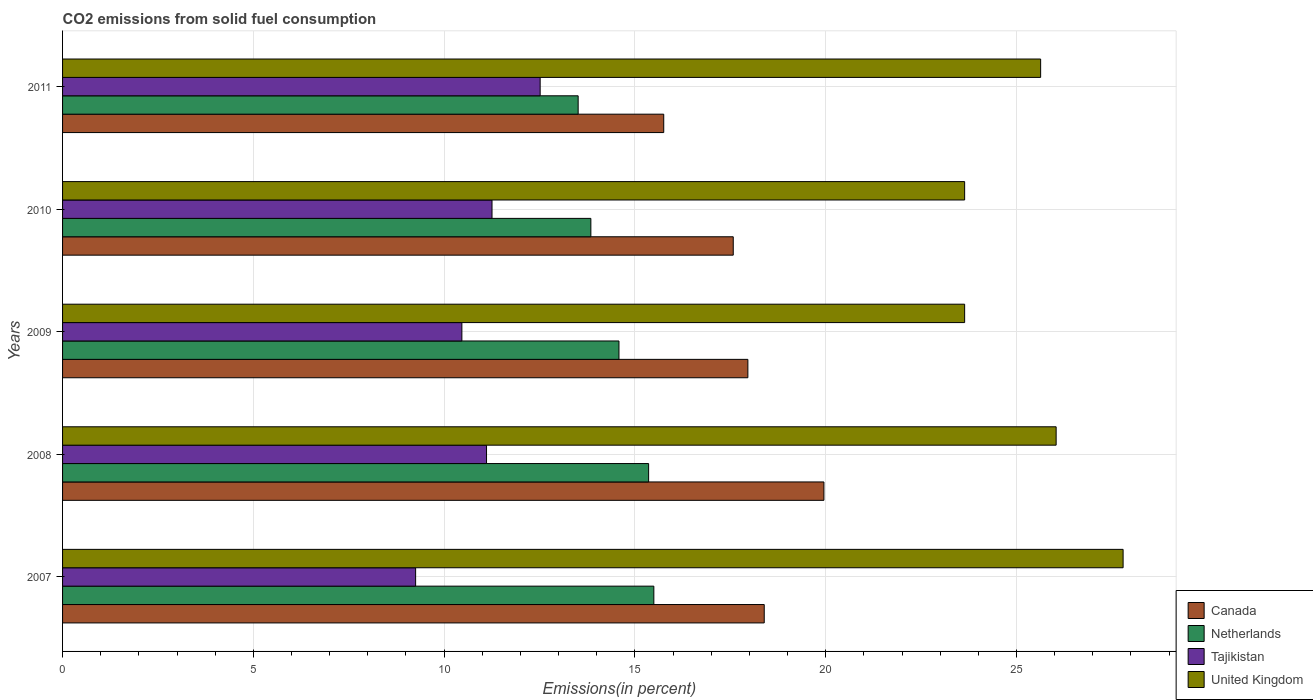Are the number of bars per tick equal to the number of legend labels?
Your answer should be very brief. Yes. Are the number of bars on each tick of the Y-axis equal?
Make the answer very short. Yes. How many bars are there on the 5th tick from the top?
Offer a very short reply. 4. What is the label of the 5th group of bars from the top?
Your answer should be compact. 2007. In how many cases, is the number of bars for a given year not equal to the number of legend labels?
Your response must be concise. 0. What is the total CO2 emitted in Netherlands in 2007?
Offer a very short reply. 15.5. Across all years, what is the maximum total CO2 emitted in Netherlands?
Your response must be concise. 15.5. Across all years, what is the minimum total CO2 emitted in Tajikistan?
Give a very brief answer. 9.25. In which year was the total CO2 emitted in Canada maximum?
Offer a very short reply. 2008. What is the total total CO2 emitted in United Kingdom in the graph?
Offer a terse response. 126.75. What is the difference between the total CO2 emitted in Netherlands in 2009 and that in 2010?
Provide a short and direct response. 0.74. What is the difference between the total CO2 emitted in Netherlands in 2009 and the total CO2 emitted in United Kingdom in 2007?
Offer a terse response. -13.21. What is the average total CO2 emitted in Tajikistan per year?
Provide a succinct answer. 10.92. In the year 2011, what is the difference between the total CO2 emitted in Netherlands and total CO2 emitted in United Kingdom?
Your response must be concise. -12.12. In how many years, is the total CO2 emitted in Tajikistan greater than 28 %?
Provide a short and direct response. 0. What is the ratio of the total CO2 emitted in Tajikistan in 2009 to that in 2011?
Make the answer very short. 0.84. What is the difference between the highest and the second highest total CO2 emitted in Tajikistan?
Keep it short and to the point. 1.26. What is the difference between the highest and the lowest total CO2 emitted in Tajikistan?
Ensure brevity in your answer.  3.26. In how many years, is the total CO2 emitted in Canada greater than the average total CO2 emitted in Canada taken over all years?
Offer a terse response. 3. Is the sum of the total CO2 emitted in Netherlands in 2009 and 2010 greater than the maximum total CO2 emitted in United Kingdom across all years?
Ensure brevity in your answer.  Yes. Is it the case that in every year, the sum of the total CO2 emitted in Tajikistan and total CO2 emitted in Netherlands is greater than the sum of total CO2 emitted in Canada and total CO2 emitted in United Kingdom?
Offer a very short reply. No. What does the 3rd bar from the top in 2008 represents?
Make the answer very short. Netherlands. How many legend labels are there?
Provide a succinct answer. 4. What is the title of the graph?
Your answer should be very brief. CO2 emissions from solid fuel consumption. What is the label or title of the X-axis?
Make the answer very short. Emissions(in percent). What is the label or title of the Y-axis?
Ensure brevity in your answer.  Years. What is the Emissions(in percent) of Canada in 2007?
Keep it short and to the point. 18.39. What is the Emissions(in percent) in Netherlands in 2007?
Keep it short and to the point. 15.5. What is the Emissions(in percent) in Tajikistan in 2007?
Your response must be concise. 9.25. What is the Emissions(in percent) in United Kingdom in 2007?
Give a very brief answer. 27.79. What is the Emissions(in percent) in Canada in 2008?
Keep it short and to the point. 19.95. What is the Emissions(in percent) of Netherlands in 2008?
Offer a terse response. 15.36. What is the Emissions(in percent) in Tajikistan in 2008?
Your answer should be compact. 11.11. What is the Emissions(in percent) of United Kingdom in 2008?
Your response must be concise. 26.04. What is the Emissions(in percent) of Canada in 2009?
Provide a short and direct response. 17.96. What is the Emissions(in percent) of Netherlands in 2009?
Offer a very short reply. 14.58. What is the Emissions(in percent) of Tajikistan in 2009?
Your answer should be compact. 10.47. What is the Emissions(in percent) in United Kingdom in 2009?
Offer a very short reply. 23.64. What is the Emissions(in percent) of Canada in 2010?
Keep it short and to the point. 17.58. What is the Emissions(in percent) of Netherlands in 2010?
Ensure brevity in your answer.  13.85. What is the Emissions(in percent) of Tajikistan in 2010?
Your answer should be compact. 11.25. What is the Emissions(in percent) in United Kingdom in 2010?
Offer a terse response. 23.64. What is the Emissions(in percent) of Canada in 2011?
Offer a terse response. 15.76. What is the Emissions(in percent) of Netherlands in 2011?
Your answer should be very brief. 13.51. What is the Emissions(in percent) of Tajikistan in 2011?
Your answer should be very brief. 12.52. What is the Emissions(in percent) of United Kingdom in 2011?
Provide a short and direct response. 25.63. Across all years, what is the maximum Emissions(in percent) in Canada?
Your answer should be very brief. 19.95. Across all years, what is the maximum Emissions(in percent) in Netherlands?
Give a very brief answer. 15.5. Across all years, what is the maximum Emissions(in percent) in Tajikistan?
Ensure brevity in your answer.  12.52. Across all years, what is the maximum Emissions(in percent) of United Kingdom?
Your answer should be compact. 27.79. Across all years, what is the minimum Emissions(in percent) in Canada?
Ensure brevity in your answer.  15.76. Across all years, what is the minimum Emissions(in percent) of Netherlands?
Your response must be concise. 13.51. Across all years, what is the minimum Emissions(in percent) in Tajikistan?
Your answer should be very brief. 9.25. Across all years, what is the minimum Emissions(in percent) of United Kingdom?
Offer a very short reply. 23.64. What is the total Emissions(in percent) of Canada in the graph?
Make the answer very short. 89.64. What is the total Emissions(in percent) of Netherlands in the graph?
Provide a short and direct response. 72.8. What is the total Emissions(in percent) of Tajikistan in the graph?
Offer a very short reply. 54.6. What is the total Emissions(in percent) of United Kingdom in the graph?
Your answer should be very brief. 126.75. What is the difference between the Emissions(in percent) of Canada in 2007 and that in 2008?
Make the answer very short. -1.56. What is the difference between the Emissions(in percent) in Netherlands in 2007 and that in 2008?
Keep it short and to the point. 0.14. What is the difference between the Emissions(in percent) in Tajikistan in 2007 and that in 2008?
Provide a short and direct response. -1.86. What is the difference between the Emissions(in percent) in United Kingdom in 2007 and that in 2008?
Your answer should be compact. 1.75. What is the difference between the Emissions(in percent) of Canada in 2007 and that in 2009?
Ensure brevity in your answer.  0.43. What is the difference between the Emissions(in percent) of Netherlands in 2007 and that in 2009?
Give a very brief answer. 0.91. What is the difference between the Emissions(in percent) in Tajikistan in 2007 and that in 2009?
Offer a terse response. -1.21. What is the difference between the Emissions(in percent) in United Kingdom in 2007 and that in 2009?
Offer a terse response. 4.15. What is the difference between the Emissions(in percent) in Canada in 2007 and that in 2010?
Provide a short and direct response. 0.81. What is the difference between the Emissions(in percent) of Netherlands in 2007 and that in 2010?
Ensure brevity in your answer.  1.65. What is the difference between the Emissions(in percent) in Tajikistan in 2007 and that in 2010?
Ensure brevity in your answer.  -2. What is the difference between the Emissions(in percent) in United Kingdom in 2007 and that in 2010?
Keep it short and to the point. 4.15. What is the difference between the Emissions(in percent) of Canada in 2007 and that in 2011?
Offer a very short reply. 2.63. What is the difference between the Emissions(in percent) in Netherlands in 2007 and that in 2011?
Offer a terse response. 1.98. What is the difference between the Emissions(in percent) in Tajikistan in 2007 and that in 2011?
Give a very brief answer. -3.26. What is the difference between the Emissions(in percent) of United Kingdom in 2007 and that in 2011?
Your answer should be very brief. 2.16. What is the difference between the Emissions(in percent) of Canada in 2008 and that in 2009?
Ensure brevity in your answer.  1.99. What is the difference between the Emissions(in percent) in Netherlands in 2008 and that in 2009?
Your response must be concise. 0.78. What is the difference between the Emissions(in percent) of Tajikistan in 2008 and that in 2009?
Provide a succinct answer. 0.65. What is the difference between the Emissions(in percent) in United Kingdom in 2008 and that in 2009?
Your answer should be compact. 2.4. What is the difference between the Emissions(in percent) in Canada in 2008 and that in 2010?
Your answer should be compact. 2.38. What is the difference between the Emissions(in percent) in Netherlands in 2008 and that in 2010?
Ensure brevity in your answer.  1.51. What is the difference between the Emissions(in percent) in Tajikistan in 2008 and that in 2010?
Keep it short and to the point. -0.14. What is the difference between the Emissions(in percent) in United Kingdom in 2008 and that in 2010?
Provide a short and direct response. 2.4. What is the difference between the Emissions(in percent) in Canada in 2008 and that in 2011?
Provide a short and direct response. 4.2. What is the difference between the Emissions(in percent) in Netherlands in 2008 and that in 2011?
Offer a terse response. 1.85. What is the difference between the Emissions(in percent) in Tajikistan in 2008 and that in 2011?
Make the answer very short. -1.41. What is the difference between the Emissions(in percent) of United Kingdom in 2008 and that in 2011?
Your answer should be compact. 0.41. What is the difference between the Emissions(in percent) in Canada in 2009 and that in 2010?
Provide a short and direct response. 0.38. What is the difference between the Emissions(in percent) of Netherlands in 2009 and that in 2010?
Make the answer very short. 0.74. What is the difference between the Emissions(in percent) in Tajikistan in 2009 and that in 2010?
Make the answer very short. -0.79. What is the difference between the Emissions(in percent) in Canada in 2009 and that in 2011?
Give a very brief answer. 2.21. What is the difference between the Emissions(in percent) of Netherlands in 2009 and that in 2011?
Your answer should be very brief. 1.07. What is the difference between the Emissions(in percent) in Tajikistan in 2009 and that in 2011?
Give a very brief answer. -2.05. What is the difference between the Emissions(in percent) in United Kingdom in 2009 and that in 2011?
Your answer should be compact. -1.99. What is the difference between the Emissions(in percent) in Canada in 2010 and that in 2011?
Make the answer very short. 1.82. What is the difference between the Emissions(in percent) in Netherlands in 2010 and that in 2011?
Provide a succinct answer. 0.33. What is the difference between the Emissions(in percent) in Tajikistan in 2010 and that in 2011?
Provide a succinct answer. -1.26. What is the difference between the Emissions(in percent) in United Kingdom in 2010 and that in 2011?
Provide a short and direct response. -1.99. What is the difference between the Emissions(in percent) of Canada in 2007 and the Emissions(in percent) of Netherlands in 2008?
Offer a terse response. 3.03. What is the difference between the Emissions(in percent) of Canada in 2007 and the Emissions(in percent) of Tajikistan in 2008?
Make the answer very short. 7.28. What is the difference between the Emissions(in percent) in Canada in 2007 and the Emissions(in percent) in United Kingdom in 2008?
Make the answer very short. -7.65. What is the difference between the Emissions(in percent) in Netherlands in 2007 and the Emissions(in percent) in Tajikistan in 2008?
Your answer should be very brief. 4.39. What is the difference between the Emissions(in percent) of Netherlands in 2007 and the Emissions(in percent) of United Kingdom in 2008?
Keep it short and to the point. -10.54. What is the difference between the Emissions(in percent) in Tajikistan in 2007 and the Emissions(in percent) in United Kingdom in 2008?
Your response must be concise. -16.79. What is the difference between the Emissions(in percent) in Canada in 2007 and the Emissions(in percent) in Netherlands in 2009?
Offer a very short reply. 3.81. What is the difference between the Emissions(in percent) in Canada in 2007 and the Emissions(in percent) in Tajikistan in 2009?
Offer a terse response. 7.92. What is the difference between the Emissions(in percent) in Canada in 2007 and the Emissions(in percent) in United Kingdom in 2009?
Provide a short and direct response. -5.25. What is the difference between the Emissions(in percent) of Netherlands in 2007 and the Emissions(in percent) of Tajikistan in 2009?
Ensure brevity in your answer.  5.03. What is the difference between the Emissions(in percent) of Netherlands in 2007 and the Emissions(in percent) of United Kingdom in 2009?
Make the answer very short. -8.15. What is the difference between the Emissions(in percent) in Tajikistan in 2007 and the Emissions(in percent) in United Kingdom in 2009?
Offer a terse response. -14.39. What is the difference between the Emissions(in percent) in Canada in 2007 and the Emissions(in percent) in Netherlands in 2010?
Keep it short and to the point. 4.54. What is the difference between the Emissions(in percent) in Canada in 2007 and the Emissions(in percent) in Tajikistan in 2010?
Your response must be concise. 7.13. What is the difference between the Emissions(in percent) of Canada in 2007 and the Emissions(in percent) of United Kingdom in 2010?
Make the answer very short. -5.25. What is the difference between the Emissions(in percent) in Netherlands in 2007 and the Emissions(in percent) in Tajikistan in 2010?
Ensure brevity in your answer.  4.24. What is the difference between the Emissions(in percent) of Netherlands in 2007 and the Emissions(in percent) of United Kingdom in 2010?
Your answer should be very brief. -8.15. What is the difference between the Emissions(in percent) in Tajikistan in 2007 and the Emissions(in percent) in United Kingdom in 2010?
Your answer should be compact. -14.39. What is the difference between the Emissions(in percent) of Canada in 2007 and the Emissions(in percent) of Netherlands in 2011?
Make the answer very short. 4.88. What is the difference between the Emissions(in percent) of Canada in 2007 and the Emissions(in percent) of Tajikistan in 2011?
Ensure brevity in your answer.  5.87. What is the difference between the Emissions(in percent) in Canada in 2007 and the Emissions(in percent) in United Kingdom in 2011?
Ensure brevity in your answer.  -7.24. What is the difference between the Emissions(in percent) of Netherlands in 2007 and the Emissions(in percent) of Tajikistan in 2011?
Offer a very short reply. 2.98. What is the difference between the Emissions(in percent) of Netherlands in 2007 and the Emissions(in percent) of United Kingdom in 2011?
Your answer should be compact. -10.14. What is the difference between the Emissions(in percent) of Tajikistan in 2007 and the Emissions(in percent) of United Kingdom in 2011?
Your answer should be compact. -16.38. What is the difference between the Emissions(in percent) in Canada in 2008 and the Emissions(in percent) in Netherlands in 2009?
Make the answer very short. 5.37. What is the difference between the Emissions(in percent) in Canada in 2008 and the Emissions(in percent) in Tajikistan in 2009?
Your answer should be very brief. 9.49. What is the difference between the Emissions(in percent) of Canada in 2008 and the Emissions(in percent) of United Kingdom in 2009?
Your answer should be compact. -3.69. What is the difference between the Emissions(in percent) in Netherlands in 2008 and the Emissions(in percent) in Tajikistan in 2009?
Give a very brief answer. 4.89. What is the difference between the Emissions(in percent) of Netherlands in 2008 and the Emissions(in percent) of United Kingdom in 2009?
Give a very brief answer. -8.28. What is the difference between the Emissions(in percent) in Tajikistan in 2008 and the Emissions(in percent) in United Kingdom in 2009?
Make the answer very short. -12.53. What is the difference between the Emissions(in percent) in Canada in 2008 and the Emissions(in percent) in Netherlands in 2010?
Make the answer very short. 6.11. What is the difference between the Emissions(in percent) of Canada in 2008 and the Emissions(in percent) of Tajikistan in 2010?
Offer a very short reply. 8.7. What is the difference between the Emissions(in percent) in Canada in 2008 and the Emissions(in percent) in United Kingdom in 2010?
Provide a short and direct response. -3.69. What is the difference between the Emissions(in percent) of Netherlands in 2008 and the Emissions(in percent) of Tajikistan in 2010?
Your response must be concise. 4.1. What is the difference between the Emissions(in percent) of Netherlands in 2008 and the Emissions(in percent) of United Kingdom in 2010?
Give a very brief answer. -8.28. What is the difference between the Emissions(in percent) of Tajikistan in 2008 and the Emissions(in percent) of United Kingdom in 2010?
Give a very brief answer. -12.53. What is the difference between the Emissions(in percent) of Canada in 2008 and the Emissions(in percent) of Netherlands in 2011?
Your response must be concise. 6.44. What is the difference between the Emissions(in percent) in Canada in 2008 and the Emissions(in percent) in Tajikistan in 2011?
Give a very brief answer. 7.44. What is the difference between the Emissions(in percent) of Canada in 2008 and the Emissions(in percent) of United Kingdom in 2011?
Offer a terse response. -5.68. What is the difference between the Emissions(in percent) of Netherlands in 2008 and the Emissions(in percent) of Tajikistan in 2011?
Offer a terse response. 2.84. What is the difference between the Emissions(in percent) of Netherlands in 2008 and the Emissions(in percent) of United Kingdom in 2011?
Provide a short and direct response. -10.27. What is the difference between the Emissions(in percent) in Tajikistan in 2008 and the Emissions(in percent) in United Kingdom in 2011?
Ensure brevity in your answer.  -14.52. What is the difference between the Emissions(in percent) in Canada in 2009 and the Emissions(in percent) in Netherlands in 2010?
Keep it short and to the point. 4.12. What is the difference between the Emissions(in percent) of Canada in 2009 and the Emissions(in percent) of Tajikistan in 2010?
Give a very brief answer. 6.71. What is the difference between the Emissions(in percent) in Canada in 2009 and the Emissions(in percent) in United Kingdom in 2010?
Make the answer very short. -5.68. What is the difference between the Emissions(in percent) of Netherlands in 2009 and the Emissions(in percent) of Tajikistan in 2010?
Offer a very short reply. 3.33. What is the difference between the Emissions(in percent) of Netherlands in 2009 and the Emissions(in percent) of United Kingdom in 2010?
Your answer should be very brief. -9.06. What is the difference between the Emissions(in percent) in Tajikistan in 2009 and the Emissions(in percent) in United Kingdom in 2010?
Ensure brevity in your answer.  -13.18. What is the difference between the Emissions(in percent) of Canada in 2009 and the Emissions(in percent) of Netherlands in 2011?
Provide a succinct answer. 4.45. What is the difference between the Emissions(in percent) of Canada in 2009 and the Emissions(in percent) of Tajikistan in 2011?
Provide a short and direct response. 5.44. What is the difference between the Emissions(in percent) of Canada in 2009 and the Emissions(in percent) of United Kingdom in 2011?
Your response must be concise. -7.67. What is the difference between the Emissions(in percent) of Netherlands in 2009 and the Emissions(in percent) of Tajikistan in 2011?
Make the answer very short. 2.07. What is the difference between the Emissions(in percent) in Netherlands in 2009 and the Emissions(in percent) in United Kingdom in 2011?
Your answer should be compact. -11.05. What is the difference between the Emissions(in percent) of Tajikistan in 2009 and the Emissions(in percent) of United Kingdom in 2011?
Keep it short and to the point. -15.17. What is the difference between the Emissions(in percent) in Canada in 2010 and the Emissions(in percent) in Netherlands in 2011?
Provide a succinct answer. 4.06. What is the difference between the Emissions(in percent) of Canada in 2010 and the Emissions(in percent) of Tajikistan in 2011?
Ensure brevity in your answer.  5.06. What is the difference between the Emissions(in percent) of Canada in 2010 and the Emissions(in percent) of United Kingdom in 2011?
Keep it short and to the point. -8.06. What is the difference between the Emissions(in percent) in Netherlands in 2010 and the Emissions(in percent) in Tajikistan in 2011?
Your response must be concise. 1.33. What is the difference between the Emissions(in percent) of Netherlands in 2010 and the Emissions(in percent) of United Kingdom in 2011?
Give a very brief answer. -11.79. What is the difference between the Emissions(in percent) of Tajikistan in 2010 and the Emissions(in percent) of United Kingdom in 2011?
Ensure brevity in your answer.  -14.38. What is the average Emissions(in percent) of Canada per year?
Give a very brief answer. 17.93. What is the average Emissions(in percent) of Netherlands per year?
Give a very brief answer. 14.56. What is the average Emissions(in percent) in Tajikistan per year?
Offer a terse response. 10.92. What is the average Emissions(in percent) of United Kingdom per year?
Make the answer very short. 25.35. In the year 2007, what is the difference between the Emissions(in percent) in Canada and Emissions(in percent) in Netherlands?
Make the answer very short. 2.89. In the year 2007, what is the difference between the Emissions(in percent) in Canada and Emissions(in percent) in Tajikistan?
Make the answer very short. 9.14. In the year 2007, what is the difference between the Emissions(in percent) of Canada and Emissions(in percent) of United Kingdom?
Keep it short and to the point. -9.41. In the year 2007, what is the difference between the Emissions(in percent) of Netherlands and Emissions(in percent) of Tajikistan?
Keep it short and to the point. 6.24. In the year 2007, what is the difference between the Emissions(in percent) in Netherlands and Emissions(in percent) in United Kingdom?
Keep it short and to the point. -12.3. In the year 2007, what is the difference between the Emissions(in percent) of Tajikistan and Emissions(in percent) of United Kingdom?
Offer a very short reply. -18.54. In the year 2008, what is the difference between the Emissions(in percent) of Canada and Emissions(in percent) of Netherlands?
Provide a short and direct response. 4.59. In the year 2008, what is the difference between the Emissions(in percent) of Canada and Emissions(in percent) of Tajikistan?
Provide a short and direct response. 8.84. In the year 2008, what is the difference between the Emissions(in percent) of Canada and Emissions(in percent) of United Kingdom?
Give a very brief answer. -6.09. In the year 2008, what is the difference between the Emissions(in percent) in Netherlands and Emissions(in percent) in Tajikistan?
Ensure brevity in your answer.  4.25. In the year 2008, what is the difference between the Emissions(in percent) in Netherlands and Emissions(in percent) in United Kingdom?
Offer a terse response. -10.68. In the year 2008, what is the difference between the Emissions(in percent) of Tajikistan and Emissions(in percent) of United Kingdom?
Your response must be concise. -14.93. In the year 2009, what is the difference between the Emissions(in percent) in Canada and Emissions(in percent) in Netherlands?
Your answer should be compact. 3.38. In the year 2009, what is the difference between the Emissions(in percent) in Canada and Emissions(in percent) in Tajikistan?
Offer a very short reply. 7.5. In the year 2009, what is the difference between the Emissions(in percent) of Canada and Emissions(in percent) of United Kingdom?
Keep it short and to the point. -5.68. In the year 2009, what is the difference between the Emissions(in percent) in Netherlands and Emissions(in percent) in Tajikistan?
Offer a terse response. 4.12. In the year 2009, what is the difference between the Emissions(in percent) of Netherlands and Emissions(in percent) of United Kingdom?
Make the answer very short. -9.06. In the year 2009, what is the difference between the Emissions(in percent) of Tajikistan and Emissions(in percent) of United Kingdom?
Ensure brevity in your answer.  -13.18. In the year 2010, what is the difference between the Emissions(in percent) of Canada and Emissions(in percent) of Netherlands?
Provide a succinct answer. 3.73. In the year 2010, what is the difference between the Emissions(in percent) of Canada and Emissions(in percent) of Tajikistan?
Ensure brevity in your answer.  6.32. In the year 2010, what is the difference between the Emissions(in percent) of Canada and Emissions(in percent) of United Kingdom?
Give a very brief answer. -6.06. In the year 2010, what is the difference between the Emissions(in percent) in Netherlands and Emissions(in percent) in Tajikistan?
Your response must be concise. 2.59. In the year 2010, what is the difference between the Emissions(in percent) in Netherlands and Emissions(in percent) in United Kingdom?
Keep it short and to the point. -9.8. In the year 2010, what is the difference between the Emissions(in percent) of Tajikistan and Emissions(in percent) of United Kingdom?
Your answer should be very brief. -12.39. In the year 2011, what is the difference between the Emissions(in percent) in Canada and Emissions(in percent) in Netherlands?
Give a very brief answer. 2.24. In the year 2011, what is the difference between the Emissions(in percent) in Canada and Emissions(in percent) in Tajikistan?
Ensure brevity in your answer.  3.24. In the year 2011, what is the difference between the Emissions(in percent) of Canada and Emissions(in percent) of United Kingdom?
Your answer should be very brief. -9.88. In the year 2011, what is the difference between the Emissions(in percent) of Netherlands and Emissions(in percent) of Tajikistan?
Provide a short and direct response. 1. In the year 2011, what is the difference between the Emissions(in percent) of Netherlands and Emissions(in percent) of United Kingdom?
Ensure brevity in your answer.  -12.12. In the year 2011, what is the difference between the Emissions(in percent) in Tajikistan and Emissions(in percent) in United Kingdom?
Provide a succinct answer. -13.12. What is the ratio of the Emissions(in percent) of Canada in 2007 to that in 2008?
Ensure brevity in your answer.  0.92. What is the ratio of the Emissions(in percent) in Netherlands in 2007 to that in 2008?
Ensure brevity in your answer.  1.01. What is the ratio of the Emissions(in percent) in Tajikistan in 2007 to that in 2008?
Offer a terse response. 0.83. What is the ratio of the Emissions(in percent) in United Kingdom in 2007 to that in 2008?
Provide a short and direct response. 1.07. What is the ratio of the Emissions(in percent) of Canada in 2007 to that in 2009?
Provide a succinct answer. 1.02. What is the ratio of the Emissions(in percent) in Netherlands in 2007 to that in 2009?
Ensure brevity in your answer.  1.06. What is the ratio of the Emissions(in percent) in Tajikistan in 2007 to that in 2009?
Provide a short and direct response. 0.88. What is the ratio of the Emissions(in percent) of United Kingdom in 2007 to that in 2009?
Make the answer very short. 1.18. What is the ratio of the Emissions(in percent) in Canada in 2007 to that in 2010?
Give a very brief answer. 1.05. What is the ratio of the Emissions(in percent) in Netherlands in 2007 to that in 2010?
Give a very brief answer. 1.12. What is the ratio of the Emissions(in percent) in Tajikistan in 2007 to that in 2010?
Ensure brevity in your answer.  0.82. What is the ratio of the Emissions(in percent) in United Kingdom in 2007 to that in 2010?
Offer a very short reply. 1.18. What is the ratio of the Emissions(in percent) in Canada in 2007 to that in 2011?
Make the answer very short. 1.17. What is the ratio of the Emissions(in percent) of Netherlands in 2007 to that in 2011?
Give a very brief answer. 1.15. What is the ratio of the Emissions(in percent) of Tajikistan in 2007 to that in 2011?
Your response must be concise. 0.74. What is the ratio of the Emissions(in percent) of United Kingdom in 2007 to that in 2011?
Your answer should be compact. 1.08. What is the ratio of the Emissions(in percent) in Canada in 2008 to that in 2009?
Provide a short and direct response. 1.11. What is the ratio of the Emissions(in percent) in Netherlands in 2008 to that in 2009?
Keep it short and to the point. 1.05. What is the ratio of the Emissions(in percent) in Tajikistan in 2008 to that in 2009?
Make the answer very short. 1.06. What is the ratio of the Emissions(in percent) in United Kingdom in 2008 to that in 2009?
Give a very brief answer. 1.1. What is the ratio of the Emissions(in percent) in Canada in 2008 to that in 2010?
Offer a very short reply. 1.14. What is the ratio of the Emissions(in percent) of Netherlands in 2008 to that in 2010?
Offer a very short reply. 1.11. What is the ratio of the Emissions(in percent) in Tajikistan in 2008 to that in 2010?
Your answer should be very brief. 0.99. What is the ratio of the Emissions(in percent) in United Kingdom in 2008 to that in 2010?
Your answer should be very brief. 1.1. What is the ratio of the Emissions(in percent) in Canada in 2008 to that in 2011?
Ensure brevity in your answer.  1.27. What is the ratio of the Emissions(in percent) of Netherlands in 2008 to that in 2011?
Offer a terse response. 1.14. What is the ratio of the Emissions(in percent) of Tajikistan in 2008 to that in 2011?
Offer a terse response. 0.89. What is the ratio of the Emissions(in percent) of United Kingdom in 2008 to that in 2011?
Your answer should be very brief. 1.02. What is the ratio of the Emissions(in percent) in Canada in 2009 to that in 2010?
Your answer should be very brief. 1.02. What is the ratio of the Emissions(in percent) in Netherlands in 2009 to that in 2010?
Ensure brevity in your answer.  1.05. What is the ratio of the Emissions(in percent) of Tajikistan in 2009 to that in 2010?
Your response must be concise. 0.93. What is the ratio of the Emissions(in percent) in Canada in 2009 to that in 2011?
Offer a terse response. 1.14. What is the ratio of the Emissions(in percent) in Netherlands in 2009 to that in 2011?
Provide a succinct answer. 1.08. What is the ratio of the Emissions(in percent) in Tajikistan in 2009 to that in 2011?
Provide a short and direct response. 0.84. What is the ratio of the Emissions(in percent) in United Kingdom in 2009 to that in 2011?
Provide a succinct answer. 0.92. What is the ratio of the Emissions(in percent) of Canada in 2010 to that in 2011?
Offer a very short reply. 1.12. What is the ratio of the Emissions(in percent) in Netherlands in 2010 to that in 2011?
Provide a succinct answer. 1.02. What is the ratio of the Emissions(in percent) of Tajikistan in 2010 to that in 2011?
Ensure brevity in your answer.  0.9. What is the ratio of the Emissions(in percent) of United Kingdom in 2010 to that in 2011?
Keep it short and to the point. 0.92. What is the difference between the highest and the second highest Emissions(in percent) in Canada?
Offer a very short reply. 1.56. What is the difference between the highest and the second highest Emissions(in percent) in Netherlands?
Provide a short and direct response. 0.14. What is the difference between the highest and the second highest Emissions(in percent) of Tajikistan?
Keep it short and to the point. 1.26. What is the difference between the highest and the second highest Emissions(in percent) of United Kingdom?
Offer a very short reply. 1.75. What is the difference between the highest and the lowest Emissions(in percent) in Canada?
Your answer should be compact. 4.2. What is the difference between the highest and the lowest Emissions(in percent) of Netherlands?
Your answer should be compact. 1.98. What is the difference between the highest and the lowest Emissions(in percent) in Tajikistan?
Provide a short and direct response. 3.26. What is the difference between the highest and the lowest Emissions(in percent) in United Kingdom?
Your answer should be very brief. 4.15. 